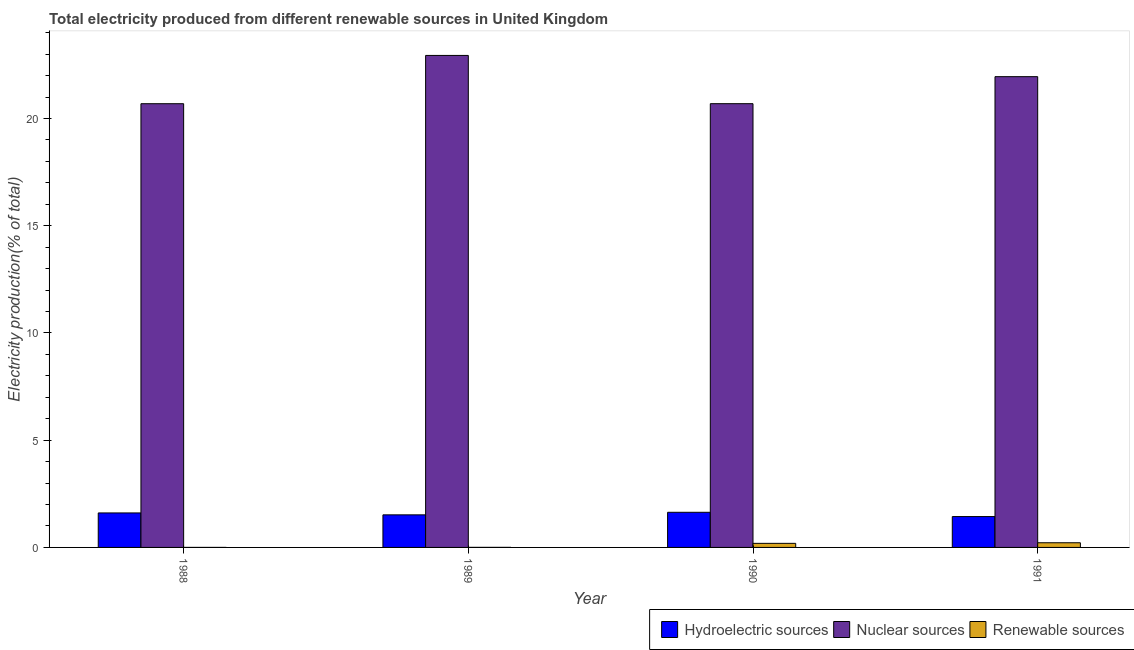How many bars are there on the 2nd tick from the left?
Provide a succinct answer. 3. In how many cases, is the number of bars for a given year not equal to the number of legend labels?
Keep it short and to the point. 0. What is the percentage of electricity produced by nuclear sources in 1988?
Make the answer very short. 20.69. Across all years, what is the maximum percentage of electricity produced by renewable sources?
Make the answer very short. 0.22. Across all years, what is the minimum percentage of electricity produced by nuclear sources?
Offer a terse response. 20.69. In which year was the percentage of electricity produced by renewable sources maximum?
Provide a succinct answer. 1991. In which year was the percentage of electricity produced by hydroelectric sources minimum?
Make the answer very short. 1991. What is the total percentage of electricity produced by renewable sources in the graph?
Make the answer very short. 0.41. What is the difference between the percentage of electricity produced by renewable sources in 1988 and that in 1990?
Give a very brief answer. -0.19. What is the difference between the percentage of electricity produced by hydroelectric sources in 1988 and the percentage of electricity produced by renewable sources in 1990?
Make the answer very short. -0.03. What is the average percentage of electricity produced by nuclear sources per year?
Offer a very short reply. 21.57. What is the ratio of the percentage of electricity produced by nuclear sources in 1989 to that in 1990?
Give a very brief answer. 1.11. What is the difference between the highest and the second highest percentage of electricity produced by nuclear sources?
Give a very brief answer. 0.99. What is the difference between the highest and the lowest percentage of electricity produced by hydroelectric sources?
Your answer should be very brief. 0.2. Is the sum of the percentage of electricity produced by hydroelectric sources in 1989 and 1991 greater than the maximum percentage of electricity produced by renewable sources across all years?
Offer a terse response. Yes. What does the 3rd bar from the left in 1989 represents?
Ensure brevity in your answer.  Renewable sources. What does the 2nd bar from the right in 1991 represents?
Offer a very short reply. Nuclear sources. Are the values on the major ticks of Y-axis written in scientific E-notation?
Offer a terse response. No. Does the graph contain any zero values?
Offer a terse response. No. Does the graph contain grids?
Give a very brief answer. No. Where does the legend appear in the graph?
Provide a short and direct response. Bottom right. How many legend labels are there?
Your answer should be compact. 3. What is the title of the graph?
Make the answer very short. Total electricity produced from different renewable sources in United Kingdom. What is the label or title of the X-axis?
Provide a short and direct response. Year. What is the label or title of the Y-axis?
Give a very brief answer. Electricity production(% of total). What is the Electricity production(% of total) in Hydroelectric sources in 1988?
Offer a terse response. 1.61. What is the Electricity production(% of total) of Nuclear sources in 1988?
Make the answer very short. 20.69. What is the Electricity production(% of total) in Renewable sources in 1988?
Your response must be concise. 0. What is the Electricity production(% of total) of Hydroelectric sources in 1989?
Offer a terse response. 1.52. What is the Electricity production(% of total) in Nuclear sources in 1989?
Keep it short and to the point. 22.94. What is the Electricity production(% of total) of Renewable sources in 1989?
Make the answer very short. 0. What is the Electricity production(% of total) in Hydroelectric sources in 1990?
Your answer should be compact. 1.64. What is the Electricity production(% of total) in Nuclear sources in 1990?
Ensure brevity in your answer.  20.69. What is the Electricity production(% of total) in Renewable sources in 1990?
Offer a terse response. 0.19. What is the Electricity production(% of total) in Hydroelectric sources in 1991?
Offer a very short reply. 1.44. What is the Electricity production(% of total) in Nuclear sources in 1991?
Your answer should be compact. 21.95. What is the Electricity production(% of total) in Renewable sources in 1991?
Ensure brevity in your answer.  0.22. Across all years, what is the maximum Electricity production(% of total) of Hydroelectric sources?
Provide a succinct answer. 1.64. Across all years, what is the maximum Electricity production(% of total) in Nuclear sources?
Your response must be concise. 22.94. Across all years, what is the maximum Electricity production(% of total) of Renewable sources?
Your answer should be compact. 0.22. Across all years, what is the minimum Electricity production(% of total) in Hydroelectric sources?
Keep it short and to the point. 1.44. Across all years, what is the minimum Electricity production(% of total) in Nuclear sources?
Your answer should be very brief. 20.69. Across all years, what is the minimum Electricity production(% of total) in Renewable sources?
Make the answer very short. 0. What is the total Electricity production(% of total) in Hydroelectric sources in the graph?
Ensure brevity in your answer.  6.2. What is the total Electricity production(% of total) of Nuclear sources in the graph?
Keep it short and to the point. 86.28. What is the total Electricity production(% of total) of Renewable sources in the graph?
Give a very brief answer. 0.41. What is the difference between the Electricity production(% of total) of Hydroelectric sources in 1988 and that in 1989?
Provide a succinct answer. 0.09. What is the difference between the Electricity production(% of total) of Nuclear sources in 1988 and that in 1989?
Keep it short and to the point. -2.25. What is the difference between the Electricity production(% of total) in Renewable sources in 1988 and that in 1989?
Your response must be concise. -0. What is the difference between the Electricity production(% of total) of Hydroelectric sources in 1988 and that in 1990?
Give a very brief answer. -0.03. What is the difference between the Electricity production(% of total) of Nuclear sources in 1988 and that in 1990?
Keep it short and to the point. -0. What is the difference between the Electricity production(% of total) in Renewable sources in 1988 and that in 1990?
Give a very brief answer. -0.19. What is the difference between the Electricity production(% of total) of Hydroelectric sources in 1988 and that in 1991?
Make the answer very short. 0.17. What is the difference between the Electricity production(% of total) in Nuclear sources in 1988 and that in 1991?
Keep it short and to the point. -1.26. What is the difference between the Electricity production(% of total) of Renewable sources in 1988 and that in 1991?
Your response must be concise. -0.22. What is the difference between the Electricity production(% of total) in Hydroelectric sources in 1989 and that in 1990?
Keep it short and to the point. -0.12. What is the difference between the Electricity production(% of total) in Nuclear sources in 1989 and that in 1990?
Offer a very short reply. 2.25. What is the difference between the Electricity production(% of total) of Renewable sources in 1989 and that in 1990?
Your answer should be very brief. -0.19. What is the difference between the Electricity production(% of total) of Hydroelectric sources in 1989 and that in 1991?
Provide a succinct answer. 0.08. What is the difference between the Electricity production(% of total) of Nuclear sources in 1989 and that in 1991?
Keep it short and to the point. 0.99. What is the difference between the Electricity production(% of total) in Renewable sources in 1989 and that in 1991?
Ensure brevity in your answer.  -0.21. What is the difference between the Electricity production(% of total) in Hydroelectric sources in 1990 and that in 1991?
Keep it short and to the point. 0.2. What is the difference between the Electricity production(% of total) of Nuclear sources in 1990 and that in 1991?
Keep it short and to the point. -1.26. What is the difference between the Electricity production(% of total) in Renewable sources in 1990 and that in 1991?
Ensure brevity in your answer.  -0.03. What is the difference between the Electricity production(% of total) of Hydroelectric sources in 1988 and the Electricity production(% of total) of Nuclear sources in 1989?
Offer a terse response. -21.33. What is the difference between the Electricity production(% of total) in Hydroelectric sources in 1988 and the Electricity production(% of total) in Renewable sources in 1989?
Make the answer very short. 1.61. What is the difference between the Electricity production(% of total) of Nuclear sources in 1988 and the Electricity production(% of total) of Renewable sources in 1989?
Keep it short and to the point. 20.69. What is the difference between the Electricity production(% of total) of Hydroelectric sources in 1988 and the Electricity production(% of total) of Nuclear sources in 1990?
Make the answer very short. -19.08. What is the difference between the Electricity production(% of total) in Hydroelectric sources in 1988 and the Electricity production(% of total) in Renewable sources in 1990?
Offer a terse response. 1.42. What is the difference between the Electricity production(% of total) in Nuclear sources in 1988 and the Electricity production(% of total) in Renewable sources in 1990?
Keep it short and to the point. 20.5. What is the difference between the Electricity production(% of total) of Hydroelectric sources in 1988 and the Electricity production(% of total) of Nuclear sources in 1991?
Provide a short and direct response. -20.34. What is the difference between the Electricity production(% of total) in Hydroelectric sources in 1988 and the Electricity production(% of total) in Renewable sources in 1991?
Make the answer very short. 1.39. What is the difference between the Electricity production(% of total) in Nuclear sources in 1988 and the Electricity production(% of total) in Renewable sources in 1991?
Provide a short and direct response. 20.47. What is the difference between the Electricity production(% of total) of Hydroelectric sources in 1989 and the Electricity production(% of total) of Nuclear sources in 1990?
Offer a terse response. -19.17. What is the difference between the Electricity production(% of total) of Hydroelectric sources in 1989 and the Electricity production(% of total) of Renewable sources in 1990?
Make the answer very short. 1.33. What is the difference between the Electricity production(% of total) in Nuclear sources in 1989 and the Electricity production(% of total) in Renewable sources in 1990?
Provide a short and direct response. 22.75. What is the difference between the Electricity production(% of total) in Hydroelectric sources in 1989 and the Electricity production(% of total) in Nuclear sources in 1991?
Provide a succinct answer. -20.43. What is the difference between the Electricity production(% of total) in Hydroelectric sources in 1989 and the Electricity production(% of total) in Renewable sources in 1991?
Your answer should be compact. 1.3. What is the difference between the Electricity production(% of total) in Nuclear sources in 1989 and the Electricity production(% of total) in Renewable sources in 1991?
Make the answer very short. 22.72. What is the difference between the Electricity production(% of total) in Hydroelectric sources in 1990 and the Electricity production(% of total) in Nuclear sources in 1991?
Keep it short and to the point. -20.31. What is the difference between the Electricity production(% of total) of Hydroelectric sources in 1990 and the Electricity production(% of total) of Renewable sources in 1991?
Provide a short and direct response. 1.42. What is the difference between the Electricity production(% of total) of Nuclear sources in 1990 and the Electricity production(% of total) of Renewable sources in 1991?
Your answer should be very brief. 20.47. What is the average Electricity production(% of total) of Hydroelectric sources per year?
Ensure brevity in your answer.  1.55. What is the average Electricity production(% of total) in Nuclear sources per year?
Offer a very short reply. 21.57. What is the average Electricity production(% of total) in Renewable sources per year?
Give a very brief answer. 0.1. In the year 1988, what is the difference between the Electricity production(% of total) of Hydroelectric sources and Electricity production(% of total) of Nuclear sources?
Ensure brevity in your answer.  -19.08. In the year 1988, what is the difference between the Electricity production(% of total) in Hydroelectric sources and Electricity production(% of total) in Renewable sources?
Give a very brief answer. 1.61. In the year 1988, what is the difference between the Electricity production(% of total) in Nuclear sources and Electricity production(% of total) in Renewable sources?
Your answer should be very brief. 20.69. In the year 1989, what is the difference between the Electricity production(% of total) in Hydroelectric sources and Electricity production(% of total) in Nuclear sources?
Your answer should be compact. -21.42. In the year 1989, what is the difference between the Electricity production(% of total) in Hydroelectric sources and Electricity production(% of total) in Renewable sources?
Your answer should be very brief. 1.52. In the year 1989, what is the difference between the Electricity production(% of total) in Nuclear sources and Electricity production(% of total) in Renewable sources?
Provide a short and direct response. 22.94. In the year 1990, what is the difference between the Electricity production(% of total) in Hydroelectric sources and Electricity production(% of total) in Nuclear sources?
Your answer should be very brief. -19.05. In the year 1990, what is the difference between the Electricity production(% of total) in Hydroelectric sources and Electricity production(% of total) in Renewable sources?
Provide a short and direct response. 1.45. In the year 1990, what is the difference between the Electricity production(% of total) of Nuclear sources and Electricity production(% of total) of Renewable sources?
Keep it short and to the point. 20.5. In the year 1991, what is the difference between the Electricity production(% of total) of Hydroelectric sources and Electricity production(% of total) of Nuclear sources?
Give a very brief answer. -20.51. In the year 1991, what is the difference between the Electricity production(% of total) in Hydroelectric sources and Electricity production(% of total) in Renewable sources?
Offer a terse response. 1.22. In the year 1991, what is the difference between the Electricity production(% of total) in Nuclear sources and Electricity production(% of total) in Renewable sources?
Your answer should be very brief. 21.73. What is the ratio of the Electricity production(% of total) of Hydroelectric sources in 1988 to that in 1989?
Your answer should be very brief. 1.06. What is the ratio of the Electricity production(% of total) of Nuclear sources in 1988 to that in 1989?
Provide a succinct answer. 0.9. What is the ratio of the Electricity production(% of total) of Renewable sources in 1988 to that in 1989?
Your response must be concise. 0.11. What is the ratio of the Electricity production(% of total) of Hydroelectric sources in 1988 to that in 1990?
Your response must be concise. 0.98. What is the ratio of the Electricity production(% of total) of Nuclear sources in 1988 to that in 1990?
Provide a succinct answer. 1. What is the ratio of the Electricity production(% of total) of Renewable sources in 1988 to that in 1990?
Offer a terse response. 0. What is the ratio of the Electricity production(% of total) in Hydroelectric sources in 1988 to that in 1991?
Offer a very short reply. 1.12. What is the ratio of the Electricity production(% of total) of Nuclear sources in 1988 to that in 1991?
Your answer should be very brief. 0.94. What is the ratio of the Electricity production(% of total) in Renewable sources in 1988 to that in 1991?
Keep it short and to the point. 0. What is the ratio of the Electricity production(% of total) of Hydroelectric sources in 1989 to that in 1990?
Give a very brief answer. 0.93. What is the ratio of the Electricity production(% of total) of Nuclear sources in 1989 to that in 1990?
Your response must be concise. 1.11. What is the ratio of the Electricity production(% of total) in Renewable sources in 1989 to that in 1990?
Provide a succinct answer. 0.02. What is the ratio of the Electricity production(% of total) in Hydroelectric sources in 1989 to that in 1991?
Your response must be concise. 1.06. What is the ratio of the Electricity production(% of total) of Nuclear sources in 1989 to that in 1991?
Your answer should be compact. 1.05. What is the ratio of the Electricity production(% of total) in Renewable sources in 1989 to that in 1991?
Make the answer very short. 0.01. What is the ratio of the Electricity production(% of total) of Hydroelectric sources in 1990 to that in 1991?
Make the answer very short. 1.14. What is the ratio of the Electricity production(% of total) of Nuclear sources in 1990 to that in 1991?
Make the answer very short. 0.94. What is the ratio of the Electricity production(% of total) of Renewable sources in 1990 to that in 1991?
Provide a short and direct response. 0.87. What is the difference between the highest and the second highest Electricity production(% of total) of Hydroelectric sources?
Keep it short and to the point. 0.03. What is the difference between the highest and the second highest Electricity production(% of total) in Renewable sources?
Keep it short and to the point. 0.03. What is the difference between the highest and the lowest Electricity production(% of total) in Hydroelectric sources?
Your answer should be very brief. 0.2. What is the difference between the highest and the lowest Electricity production(% of total) in Nuclear sources?
Your answer should be compact. 2.25. What is the difference between the highest and the lowest Electricity production(% of total) of Renewable sources?
Your answer should be compact. 0.22. 